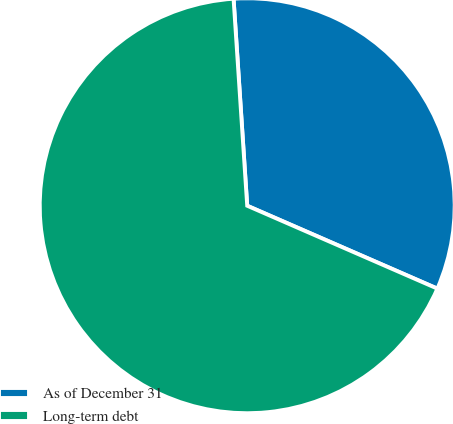<chart> <loc_0><loc_0><loc_500><loc_500><pie_chart><fcel>As of December 31<fcel>Long-term debt<nl><fcel>32.59%<fcel>67.41%<nl></chart> 